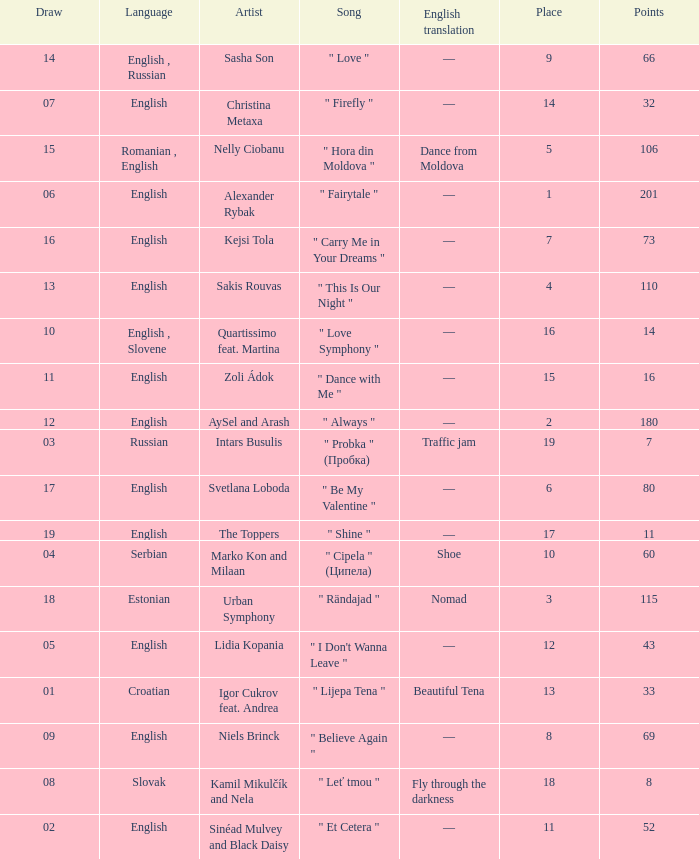What is the english translation when the language is english, draw is smaller than 16, and the artist is aysel and arash? —. 